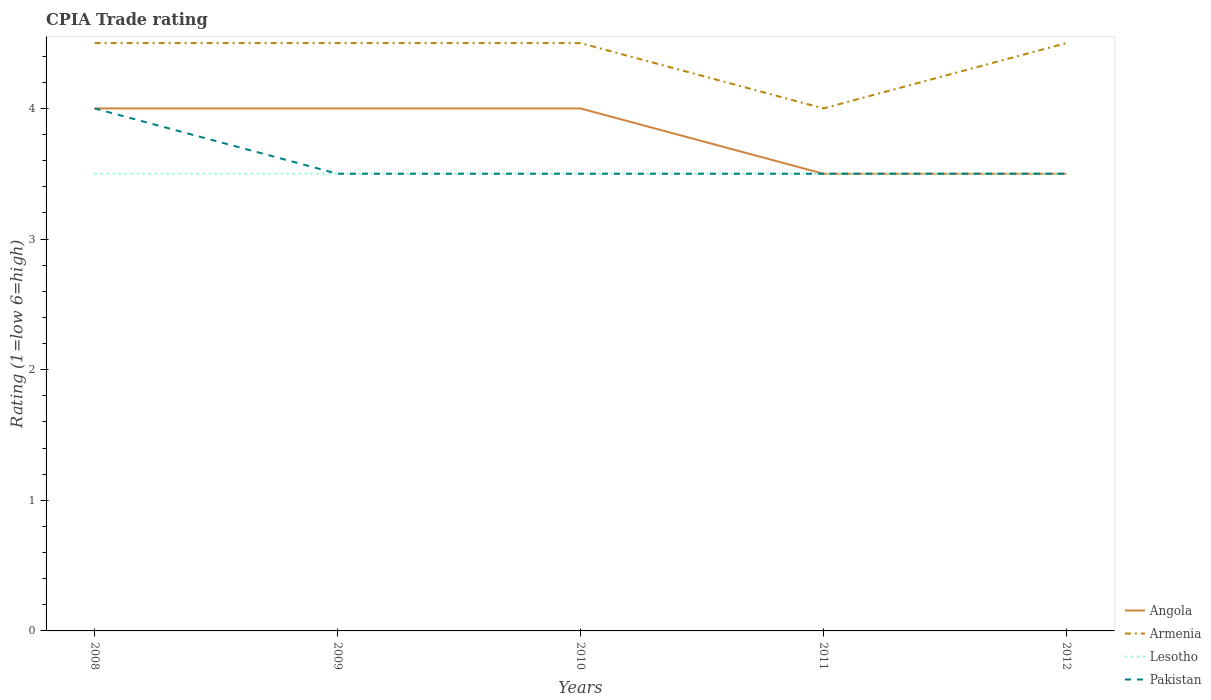Across all years, what is the maximum CPIA rating in Angola?
Provide a succinct answer. 3.5. In which year was the CPIA rating in Lesotho maximum?
Offer a terse response. 2008. How many lines are there?
Your response must be concise. 4. How many years are there in the graph?
Your response must be concise. 5. Are the values on the major ticks of Y-axis written in scientific E-notation?
Your answer should be very brief. No. Does the graph contain grids?
Offer a very short reply. No. How many legend labels are there?
Give a very brief answer. 4. How are the legend labels stacked?
Your answer should be compact. Vertical. What is the title of the graph?
Make the answer very short. CPIA Trade rating. Does "Thailand" appear as one of the legend labels in the graph?
Give a very brief answer. No. What is the label or title of the X-axis?
Offer a very short reply. Years. What is the Rating (1=low 6=high) of Lesotho in 2008?
Your answer should be very brief. 3.5. What is the Rating (1=low 6=high) in Angola in 2009?
Your response must be concise. 4. What is the Rating (1=low 6=high) of Armenia in 2009?
Give a very brief answer. 4.5. What is the Rating (1=low 6=high) of Pakistan in 2009?
Keep it short and to the point. 3.5. What is the Rating (1=low 6=high) of Pakistan in 2010?
Provide a succinct answer. 3.5. What is the Rating (1=low 6=high) in Lesotho in 2011?
Give a very brief answer. 3.5. What is the Rating (1=low 6=high) of Pakistan in 2011?
Your response must be concise. 3.5. What is the Rating (1=low 6=high) in Lesotho in 2012?
Your response must be concise. 3.5. What is the Rating (1=low 6=high) in Pakistan in 2012?
Your response must be concise. 3.5. Across all years, what is the maximum Rating (1=low 6=high) of Armenia?
Ensure brevity in your answer.  4.5. Across all years, what is the minimum Rating (1=low 6=high) in Armenia?
Ensure brevity in your answer.  4. Across all years, what is the minimum Rating (1=low 6=high) of Lesotho?
Provide a succinct answer. 3.5. What is the total Rating (1=low 6=high) in Armenia in the graph?
Make the answer very short. 22. What is the total Rating (1=low 6=high) of Lesotho in the graph?
Your response must be concise. 17.5. What is the difference between the Rating (1=low 6=high) in Armenia in 2008 and that in 2009?
Your answer should be very brief. 0. What is the difference between the Rating (1=low 6=high) in Lesotho in 2008 and that in 2009?
Ensure brevity in your answer.  0. What is the difference between the Rating (1=low 6=high) of Pakistan in 2008 and that in 2009?
Provide a succinct answer. 0.5. What is the difference between the Rating (1=low 6=high) of Pakistan in 2008 and that in 2010?
Keep it short and to the point. 0.5. What is the difference between the Rating (1=low 6=high) of Armenia in 2008 and that in 2011?
Ensure brevity in your answer.  0.5. What is the difference between the Rating (1=low 6=high) of Lesotho in 2008 and that in 2011?
Provide a short and direct response. 0. What is the difference between the Rating (1=low 6=high) of Angola in 2009 and that in 2010?
Your answer should be compact. 0. What is the difference between the Rating (1=low 6=high) in Armenia in 2009 and that in 2010?
Provide a succinct answer. 0. What is the difference between the Rating (1=low 6=high) in Pakistan in 2009 and that in 2011?
Offer a terse response. 0. What is the difference between the Rating (1=low 6=high) in Armenia in 2009 and that in 2012?
Offer a very short reply. 0. What is the difference between the Rating (1=low 6=high) of Lesotho in 2010 and that in 2011?
Your answer should be very brief. 0. What is the difference between the Rating (1=low 6=high) in Armenia in 2010 and that in 2012?
Offer a very short reply. 0. What is the difference between the Rating (1=low 6=high) of Lesotho in 2010 and that in 2012?
Provide a short and direct response. 0. What is the difference between the Rating (1=low 6=high) in Angola in 2011 and that in 2012?
Ensure brevity in your answer.  0. What is the difference between the Rating (1=low 6=high) of Armenia in 2011 and that in 2012?
Ensure brevity in your answer.  -0.5. What is the difference between the Rating (1=low 6=high) in Pakistan in 2011 and that in 2012?
Keep it short and to the point. 0. What is the difference between the Rating (1=low 6=high) of Angola in 2008 and the Rating (1=low 6=high) of Armenia in 2009?
Ensure brevity in your answer.  -0.5. What is the difference between the Rating (1=low 6=high) of Armenia in 2008 and the Rating (1=low 6=high) of Lesotho in 2009?
Provide a succinct answer. 1. What is the difference between the Rating (1=low 6=high) of Angola in 2008 and the Rating (1=low 6=high) of Lesotho in 2010?
Your response must be concise. 0.5. What is the difference between the Rating (1=low 6=high) of Angola in 2008 and the Rating (1=low 6=high) of Pakistan in 2010?
Provide a succinct answer. 0.5. What is the difference between the Rating (1=low 6=high) of Armenia in 2008 and the Rating (1=low 6=high) of Lesotho in 2010?
Provide a short and direct response. 1. What is the difference between the Rating (1=low 6=high) in Armenia in 2008 and the Rating (1=low 6=high) in Pakistan in 2010?
Provide a short and direct response. 1. What is the difference between the Rating (1=low 6=high) in Angola in 2008 and the Rating (1=low 6=high) in Armenia in 2011?
Offer a very short reply. 0. What is the difference between the Rating (1=low 6=high) of Angola in 2008 and the Rating (1=low 6=high) of Lesotho in 2011?
Provide a succinct answer. 0.5. What is the difference between the Rating (1=low 6=high) of Angola in 2008 and the Rating (1=low 6=high) of Pakistan in 2011?
Your response must be concise. 0.5. What is the difference between the Rating (1=low 6=high) of Armenia in 2008 and the Rating (1=low 6=high) of Lesotho in 2011?
Make the answer very short. 1. What is the difference between the Rating (1=low 6=high) in Armenia in 2008 and the Rating (1=low 6=high) in Pakistan in 2011?
Offer a very short reply. 1. What is the difference between the Rating (1=low 6=high) of Lesotho in 2008 and the Rating (1=low 6=high) of Pakistan in 2011?
Provide a succinct answer. 0. What is the difference between the Rating (1=low 6=high) of Angola in 2008 and the Rating (1=low 6=high) of Pakistan in 2012?
Offer a terse response. 0.5. What is the difference between the Rating (1=low 6=high) in Armenia in 2008 and the Rating (1=low 6=high) in Lesotho in 2012?
Offer a very short reply. 1. What is the difference between the Rating (1=low 6=high) in Armenia in 2009 and the Rating (1=low 6=high) in Pakistan in 2010?
Your answer should be compact. 1. What is the difference between the Rating (1=low 6=high) of Lesotho in 2009 and the Rating (1=low 6=high) of Pakistan in 2010?
Ensure brevity in your answer.  0. What is the difference between the Rating (1=low 6=high) in Angola in 2009 and the Rating (1=low 6=high) in Pakistan in 2012?
Offer a very short reply. 0.5. What is the difference between the Rating (1=low 6=high) of Armenia in 2009 and the Rating (1=low 6=high) of Lesotho in 2012?
Provide a succinct answer. 1. What is the difference between the Rating (1=low 6=high) of Lesotho in 2009 and the Rating (1=low 6=high) of Pakistan in 2012?
Provide a succinct answer. 0. What is the difference between the Rating (1=low 6=high) in Angola in 2010 and the Rating (1=low 6=high) in Armenia in 2011?
Your answer should be very brief. 0. What is the difference between the Rating (1=low 6=high) in Angola in 2010 and the Rating (1=low 6=high) in Pakistan in 2011?
Your answer should be compact. 0.5. What is the difference between the Rating (1=low 6=high) of Lesotho in 2010 and the Rating (1=low 6=high) of Pakistan in 2011?
Give a very brief answer. 0. What is the difference between the Rating (1=low 6=high) of Armenia in 2010 and the Rating (1=low 6=high) of Lesotho in 2012?
Offer a terse response. 1. What is the difference between the Rating (1=low 6=high) of Armenia in 2010 and the Rating (1=low 6=high) of Pakistan in 2012?
Give a very brief answer. 1. What is the difference between the Rating (1=low 6=high) in Lesotho in 2010 and the Rating (1=low 6=high) in Pakistan in 2012?
Offer a very short reply. 0. What is the difference between the Rating (1=low 6=high) in Angola in 2011 and the Rating (1=low 6=high) in Pakistan in 2012?
Offer a very short reply. 0. What is the difference between the Rating (1=low 6=high) of Armenia in 2011 and the Rating (1=low 6=high) of Pakistan in 2012?
Your answer should be compact. 0.5. What is the difference between the Rating (1=low 6=high) in Lesotho in 2011 and the Rating (1=low 6=high) in Pakistan in 2012?
Your answer should be very brief. 0. In the year 2008, what is the difference between the Rating (1=low 6=high) of Angola and Rating (1=low 6=high) of Armenia?
Provide a short and direct response. -0.5. In the year 2008, what is the difference between the Rating (1=low 6=high) in Angola and Rating (1=low 6=high) in Pakistan?
Your answer should be compact. 0. In the year 2008, what is the difference between the Rating (1=low 6=high) of Armenia and Rating (1=low 6=high) of Lesotho?
Make the answer very short. 1. In the year 2008, what is the difference between the Rating (1=low 6=high) of Lesotho and Rating (1=low 6=high) of Pakistan?
Make the answer very short. -0.5. In the year 2009, what is the difference between the Rating (1=low 6=high) of Angola and Rating (1=low 6=high) of Pakistan?
Your answer should be very brief. 0.5. In the year 2009, what is the difference between the Rating (1=low 6=high) in Armenia and Rating (1=low 6=high) in Pakistan?
Ensure brevity in your answer.  1. In the year 2009, what is the difference between the Rating (1=low 6=high) of Lesotho and Rating (1=low 6=high) of Pakistan?
Offer a terse response. 0. In the year 2010, what is the difference between the Rating (1=low 6=high) of Angola and Rating (1=low 6=high) of Pakistan?
Offer a very short reply. 0.5. In the year 2010, what is the difference between the Rating (1=low 6=high) in Armenia and Rating (1=low 6=high) in Lesotho?
Provide a succinct answer. 1. In the year 2010, what is the difference between the Rating (1=low 6=high) in Lesotho and Rating (1=low 6=high) in Pakistan?
Your answer should be very brief. 0. In the year 2011, what is the difference between the Rating (1=low 6=high) of Angola and Rating (1=low 6=high) of Armenia?
Provide a short and direct response. -0.5. In the year 2011, what is the difference between the Rating (1=low 6=high) of Angola and Rating (1=low 6=high) of Lesotho?
Keep it short and to the point. 0. In the year 2011, what is the difference between the Rating (1=low 6=high) of Lesotho and Rating (1=low 6=high) of Pakistan?
Keep it short and to the point. 0. In the year 2012, what is the difference between the Rating (1=low 6=high) in Angola and Rating (1=low 6=high) in Armenia?
Offer a terse response. -1. In the year 2012, what is the difference between the Rating (1=low 6=high) of Angola and Rating (1=low 6=high) of Lesotho?
Give a very brief answer. 0. In the year 2012, what is the difference between the Rating (1=low 6=high) of Angola and Rating (1=low 6=high) of Pakistan?
Your answer should be very brief. 0. In the year 2012, what is the difference between the Rating (1=low 6=high) of Armenia and Rating (1=low 6=high) of Pakistan?
Your answer should be very brief. 1. What is the ratio of the Rating (1=low 6=high) of Angola in 2008 to that in 2009?
Your answer should be very brief. 1. What is the ratio of the Rating (1=low 6=high) in Armenia in 2008 to that in 2009?
Your response must be concise. 1. What is the ratio of the Rating (1=low 6=high) in Lesotho in 2008 to that in 2010?
Your answer should be compact. 1. What is the ratio of the Rating (1=low 6=high) of Pakistan in 2008 to that in 2010?
Make the answer very short. 1.14. What is the ratio of the Rating (1=low 6=high) of Angola in 2008 to that in 2011?
Your answer should be very brief. 1.14. What is the ratio of the Rating (1=low 6=high) in Armenia in 2008 to that in 2011?
Offer a terse response. 1.12. What is the ratio of the Rating (1=low 6=high) of Pakistan in 2008 to that in 2011?
Keep it short and to the point. 1.14. What is the ratio of the Rating (1=low 6=high) of Angola in 2008 to that in 2012?
Keep it short and to the point. 1.14. What is the ratio of the Rating (1=low 6=high) in Angola in 2009 to that in 2010?
Ensure brevity in your answer.  1. What is the ratio of the Rating (1=low 6=high) of Armenia in 2009 to that in 2010?
Provide a short and direct response. 1. What is the ratio of the Rating (1=low 6=high) in Lesotho in 2009 to that in 2011?
Make the answer very short. 1. What is the ratio of the Rating (1=low 6=high) of Angola in 2009 to that in 2012?
Provide a short and direct response. 1.14. What is the ratio of the Rating (1=low 6=high) of Lesotho in 2009 to that in 2012?
Offer a terse response. 1. What is the ratio of the Rating (1=low 6=high) of Pakistan in 2009 to that in 2012?
Make the answer very short. 1. What is the ratio of the Rating (1=low 6=high) in Angola in 2010 to that in 2011?
Make the answer very short. 1.14. What is the ratio of the Rating (1=low 6=high) in Lesotho in 2010 to that in 2011?
Keep it short and to the point. 1. What is the ratio of the Rating (1=low 6=high) of Pakistan in 2010 to that in 2012?
Provide a short and direct response. 1. What is the ratio of the Rating (1=low 6=high) in Armenia in 2011 to that in 2012?
Offer a very short reply. 0.89. What is the ratio of the Rating (1=low 6=high) of Lesotho in 2011 to that in 2012?
Offer a terse response. 1. What is the ratio of the Rating (1=low 6=high) in Pakistan in 2011 to that in 2012?
Your answer should be compact. 1. What is the difference between the highest and the second highest Rating (1=low 6=high) in Armenia?
Offer a terse response. 0. What is the difference between the highest and the second highest Rating (1=low 6=high) of Lesotho?
Give a very brief answer. 0. What is the difference between the highest and the second highest Rating (1=low 6=high) of Pakistan?
Ensure brevity in your answer.  0.5. What is the difference between the highest and the lowest Rating (1=low 6=high) of Armenia?
Provide a short and direct response. 0.5. What is the difference between the highest and the lowest Rating (1=low 6=high) of Lesotho?
Provide a short and direct response. 0. What is the difference between the highest and the lowest Rating (1=low 6=high) in Pakistan?
Your answer should be compact. 0.5. 